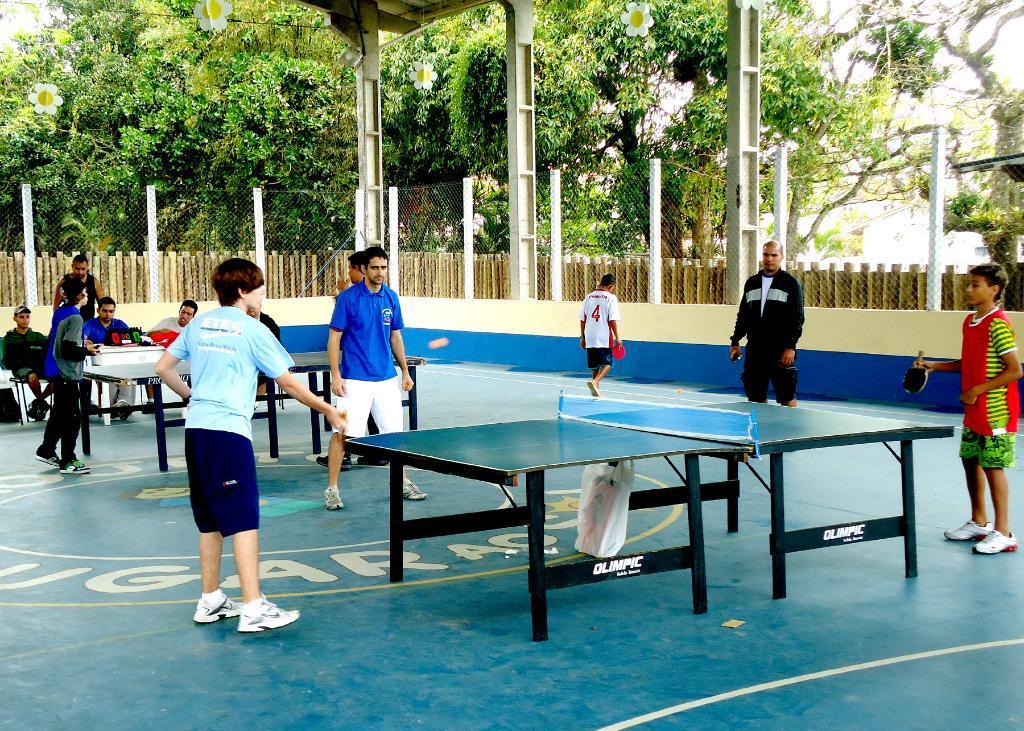How would you summarize this image in a sentence or two? In this picture we have group of people standing and sitting in the chair, another group of people standing and playing table tennis and the back ground we have wooden fence , tree , and sky. 